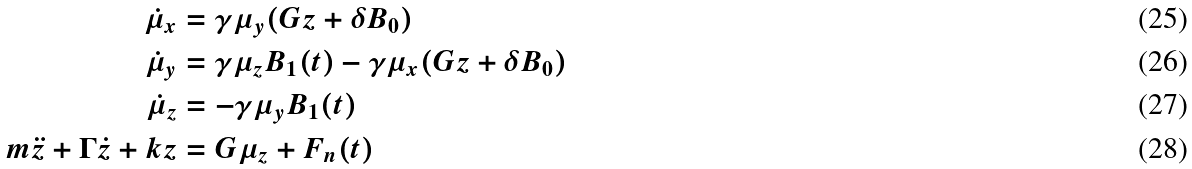Convert formula to latex. <formula><loc_0><loc_0><loc_500><loc_500>\dot { \mu } _ { x } & = \gamma \mu _ { y } ( G z + \delta B _ { 0 } ) \\ \dot { \mu } _ { y } & = \gamma \mu _ { z } B _ { 1 } ( t ) - \gamma \mu _ { x } ( G z + \delta B _ { 0 } ) \\ \dot { \mu } _ { z } & = - \gamma \mu _ { y } B _ { 1 } ( t ) \\ m \ddot { z } + \Gamma \dot { z } + k z & = G \mu _ { z } + F _ { n } ( t )</formula> 